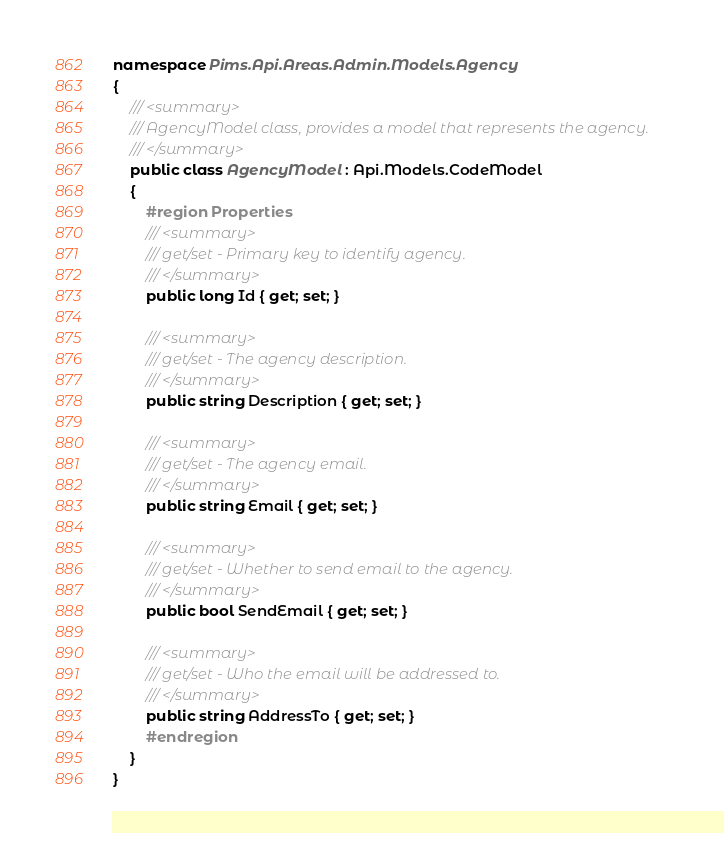Convert code to text. <code><loc_0><loc_0><loc_500><loc_500><_C#_>namespace Pims.Api.Areas.Admin.Models.Agency
{
    /// <summary>
    /// AgencyModel class, provides a model that represents the agency.
    /// </summary>
    public class AgencyModel : Api.Models.CodeModel
    {
        #region Properties
        /// <summary>
        /// get/set - Primary key to identify agency.
        /// </summary>
        public long Id { get; set; }

        /// <summary>
        /// get/set - The agency description.
        /// </summary>
        public string Description { get; set; }

        /// <summary>
        /// get/set - The agency email.
        /// </summary>
        public string Email { get; set; }

        /// <summary>
        /// get/set - Whether to send email to the agency.
        /// </summary>
        public bool SendEmail { get; set; }

        /// <summary>
        /// get/set - Who the email will be addressed to.
        /// </summary>
        public string AddressTo { get; set; }
        #endregion
    }
}
</code> 